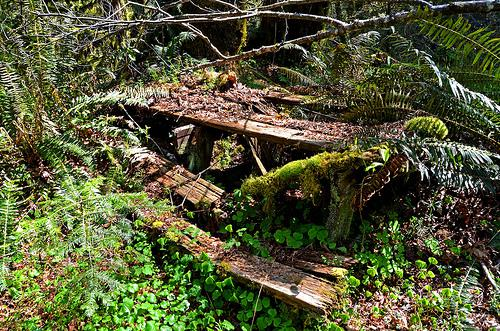Question: what color are the plants?
Choices:
A. Red.
B. Yellow.
C. White.
D. Green.
Answer with the letter. Answer: D Question: why there are branches at the top?
Choices:
A. They grew that high.
B. People put them there.
C. They fell off a tree.
D. Birds moved them.
Answer with the letter. Answer: C Question: when was the picture taken?
Choices:
A. In Fall.
B. In Summer.
C. In Winter.
D. In Spring.
Answer with the letter. Answer: B Question: where was the picture taken?
Choices:
A. In a home.
B. In a forest.
C. In a park.
D. In a city.
Answer with the letter. Answer: B 